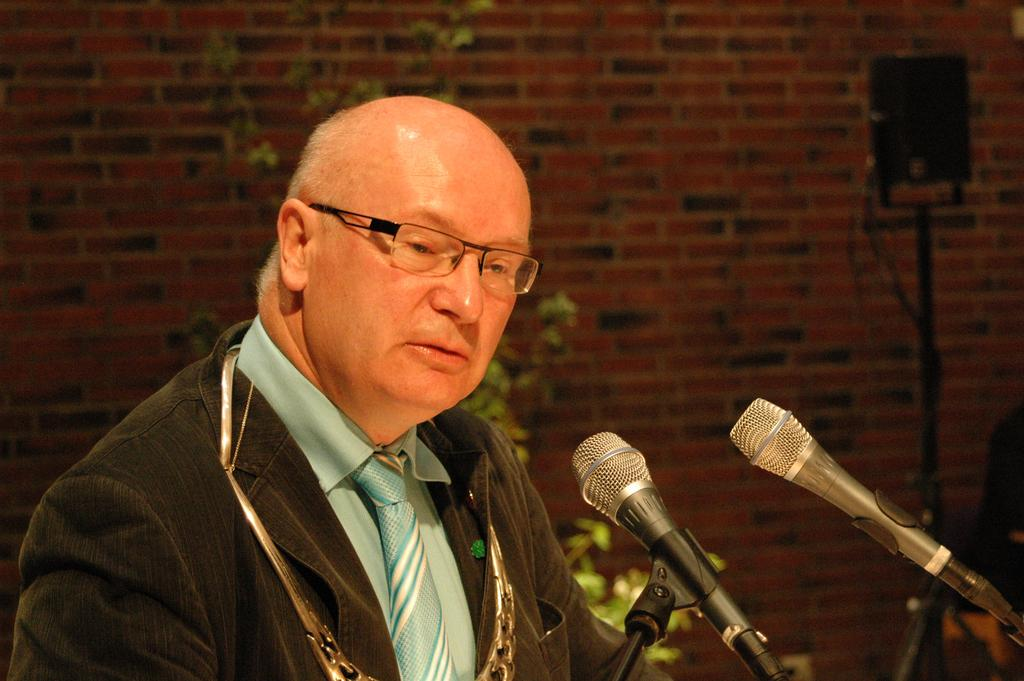What is the main subject of the image? There is a person standing in the image. What objects are in front of the person? There are two microphones in front of the person. What can be seen behind the person? There is a wall with red bricks behind the person. What type of wool is being used to create the microphone covers in the image? There is no wool or microphone covers present in the image. Can you see a knife being used by the person in the image? There is no knife visible in the image. 